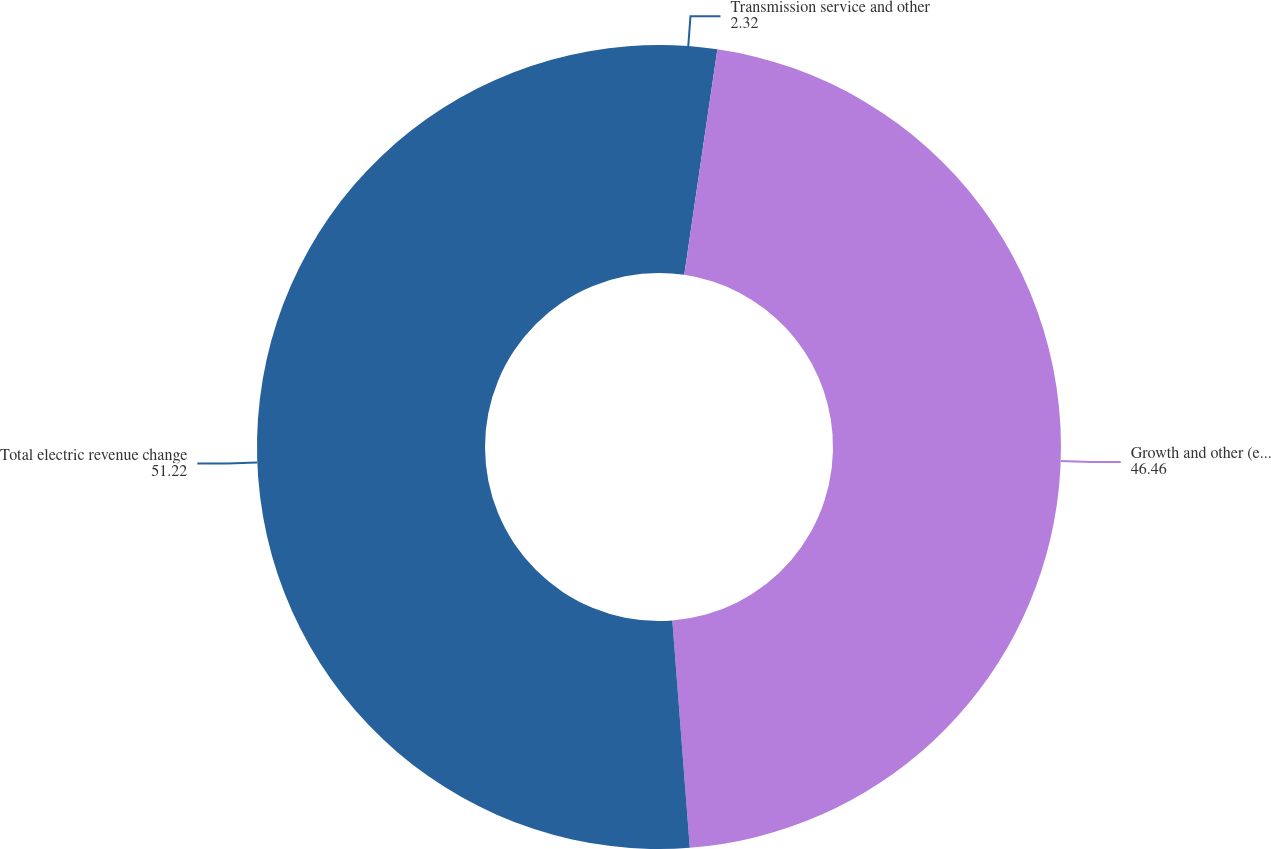Convert chart to OTSL. <chart><loc_0><loc_0><loc_500><loc_500><pie_chart><fcel>Transmission service and other<fcel>Growth and other (estimate)<fcel>Total electric revenue change<nl><fcel>2.32%<fcel>46.46%<fcel>51.22%<nl></chart> 